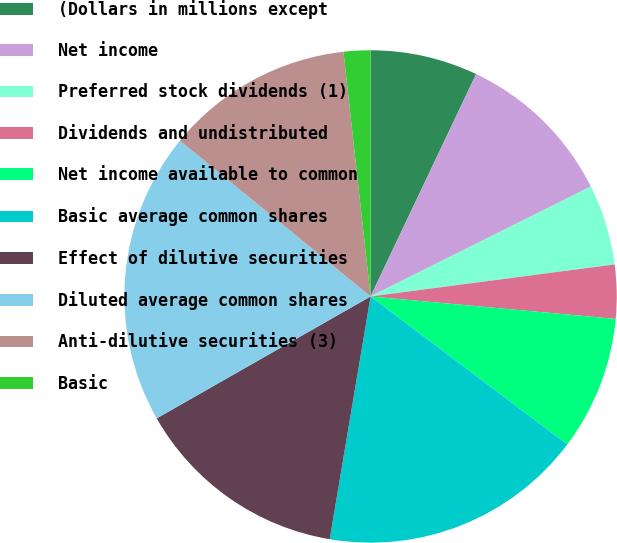Convert chart. <chart><loc_0><loc_0><loc_500><loc_500><pie_chart><fcel>(Dollars in millions except<fcel>Net income<fcel>Preferred stock dividends (1)<fcel>Dividends and undistributed<fcel>Net income available to common<fcel>Basic average common shares<fcel>Effect of dilutive securities<fcel>Diluted average common shares<fcel>Anti-dilutive securities (3)<fcel>Basic<nl><fcel>7.05%<fcel>10.58%<fcel>5.29%<fcel>3.53%<fcel>8.81%<fcel>17.39%<fcel>14.1%<fcel>19.15%<fcel>12.34%<fcel>1.76%<nl></chart> 